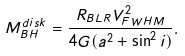Convert formula to latex. <formula><loc_0><loc_0><loc_500><loc_500>M _ { B H } ^ { d i s k } = \frac { R _ { B L R } V _ { F W H M } ^ { 2 } } { 4 G ( a ^ { 2 } + \sin ^ { 2 } i ) } .</formula> 